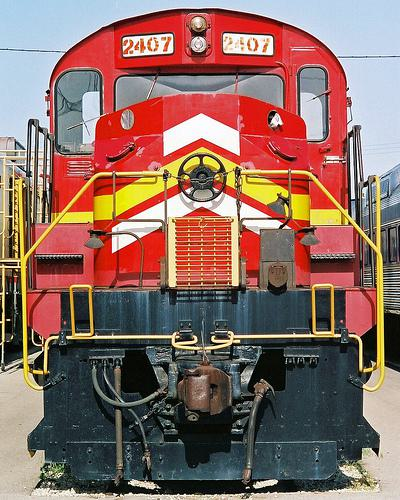What is the significance of the number 2407 on the train? The number 2407 on the train likely serves as an identification number, helping to distinguish it from other trains in the fleet. It could be useful for logistical and operational purposes, such as tracking, maintenance, and assignment to specific routes. 